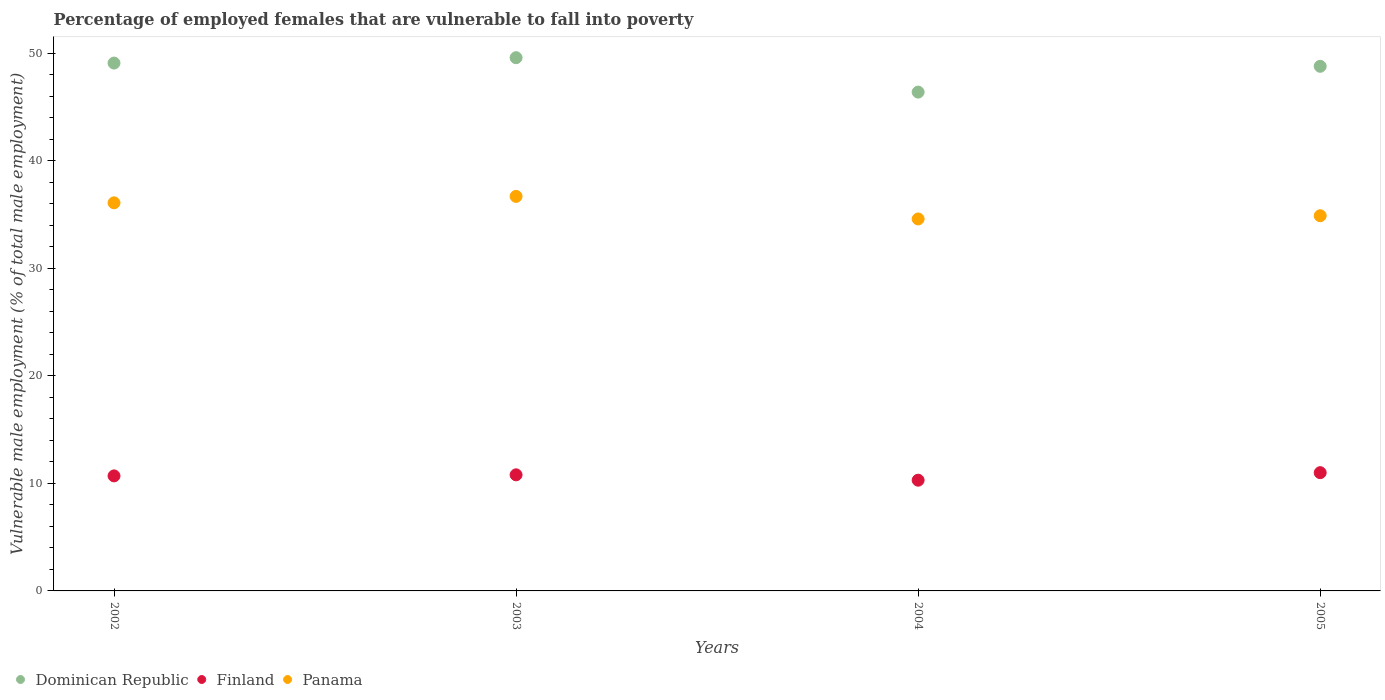Across all years, what is the maximum percentage of employed females who are vulnerable to fall into poverty in Dominican Republic?
Provide a short and direct response. 49.6. Across all years, what is the minimum percentage of employed females who are vulnerable to fall into poverty in Finland?
Provide a succinct answer. 10.3. In which year was the percentage of employed females who are vulnerable to fall into poverty in Dominican Republic maximum?
Provide a succinct answer. 2003. In which year was the percentage of employed females who are vulnerable to fall into poverty in Panama minimum?
Ensure brevity in your answer.  2004. What is the total percentage of employed females who are vulnerable to fall into poverty in Dominican Republic in the graph?
Your answer should be very brief. 193.9. What is the difference between the percentage of employed females who are vulnerable to fall into poverty in Finland in 2002 and that in 2003?
Provide a short and direct response. -0.1. What is the difference between the percentage of employed females who are vulnerable to fall into poverty in Dominican Republic in 2002 and the percentage of employed females who are vulnerable to fall into poverty in Panama in 2003?
Ensure brevity in your answer.  12.4. What is the average percentage of employed females who are vulnerable to fall into poverty in Finland per year?
Offer a very short reply. 10.7. In the year 2004, what is the difference between the percentage of employed females who are vulnerable to fall into poverty in Panama and percentage of employed females who are vulnerable to fall into poverty in Dominican Republic?
Your answer should be very brief. -11.8. What is the ratio of the percentage of employed females who are vulnerable to fall into poverty in Finland in 2002 to that in 2004?
Offer a terse response. 1.04. Is the difference between the percentage of employed females who are vulnerable to fall into poverty in Panama in 2003 and 2005 greater than the difference between the percentage of employed females who are vulnerable to fall into poverty in Dominican Republic in 2003 and 2005?
Provide a succinct answer. Yes. What is the difference between the highest and the second highest percentage of employed females who are vulnerable to fall into poverty in Finland?
Ensure brevity in your answer.  0.2. What is the difference between the highest and the lowest percentage of employed females who are vulnerable to fall into poverty in Dominican Republic?
Keep it short and to the point. 3.2. Is the sum of the percentage of employed females who are vulnerable to fall into poverty in Finland in 2003 and 2005 greater than the maximum percentage of employed females who are vulnerable to fall into poverty in Dominican Republic across all years?
Your response must be concise. No. Is it the case that in every year, the sum of the percentage of employed females who are vulnerable to fall into poverty in Panama and percentage of employed females who are vulnerable to fall into poverty in Finland  is greater than the percentage of employed females who are vulnerable to fall into poverty in Dominican Republic?
Provide a short and direct response. No. Does the percentage of employed females who are vulnerable to fall into poverty in Dominican Republic monotonically increase over the years?
Give a very brief answer. No. Is the percentage of employed females who are vulnerable to fall into poverty in Finland strictly greater than the percentage of employed females who are vulnerable to fall into poverty in Dominican Republic over the years?
Offer a very short reply. No. How many years are there in the graph?
Your answer should be very brief. 4. What is the difference between two consecutive major ticks on the Y-axis?
Keep it short and to the point. 10. Does the graph contain any zero values?
Ensure brevity in your answer.  No. Does the graph contain grids?
Your answer should be very brief. No. How many legend labels are there?
Your response must be concise. 3. How are the legend labels stacked?
Offer a terse response. Horizontal. What is the title of the graph?
Keep it short and to the point. Percentage of employed females that are vulnerable to fall into poverty. Does "Kiribati" appear as one of the legend labels in the graph?
Make the answer very short. No. What is the label or title of the Y-axis?
Make the answer very short. Vulnerable male employment (% of total male employment). What is the Vulnerable male employment (% of total male employment) in Dominican Republic in 2002?
Provide a short and direct response. 49.1. What is the Vulnerable male employment (% of total male employment) in Finland in 2002?
Offer a very short reply. 10.7. What is the Vulnerable male employment (% of total male employment) in Panama in 2002?
Make the answer very short. 36.1. What is the Vulnerable male employment (% of total male employment) of Dominican Republic in 2003?
Offer a terse response. 49.6. What is the Vulnerable male employment (% of total male employment) in Finland in 2003?
Make the answer very short. 10.8. What is the Vulnerable male employment (% of total male employment) of Panama in 2003?
Make the answer very short. 36.7. What is the Vulnerable male employment (% of total male employment) in Dominican Republic in 2004?
Keep it short and to the point. 46.4. What is the Vulnerable male employment (% of total male employment) in Finland in 2004?
Your response must be concise. 10.3. What is the Vulnerable male employment (% of total male employment) in Panama in 2004?
Offer a terse response. 34.6. What is the Vulnerable male employment (% of total male employment) of Dominican Republic in 2005?
Provide a short and direct response. 48.8. What is the Vulnerable male employment (% of total male employment) in Panama in 2005?
Your answer should be very brief. 34.9. Across all years, what is the maximum Vulnerable male employment (% of total male employment) in Dominican Republic?
Your answer should be very brief. 49.6. Across all years, what is the maximum Vulnerable male employment (% of total male employment) of Finland?
Provide a short and direct response. 11. Across all years, what is the maximum Vulnerable male employment (% of total male employment) of Panama?
Provide a short and direct response. 36.7. Across all years, what is the minimum Vulnerable male employment (% of total male employment) of Dominican Republic?
Keep it short and to the point. 46.4. Across all years, what is the minimum Vulnerable male employment (% of total male employment) of Finland?
Your response must be concise. 10.3. Across all years, what is the minimum Vulnerable male employment (% of total male employment) in Panama?
Your response must be concise. 34.6. What is the total Vulnerable male employment (% of total male employment) in Dominican Republic in the graph?
Your answer should be very brief. 193.9. What is the total Vulnerable male employment (% of total male employment) of Finland in the graph?
Your response must be concise. 42.8. What is the total Vulnerable male employment (% of total male employment) of Panama in the graph?
Provide a short and direct response. 142.3. What is the difference between the Vulnerable male employment (% of total male employment) of Dominican Republic in 2002 and that in 2003?
Offer a very short reply. -0.5. What is the difference between the Vulnerable male employment (% of total male employment) of Finland in 2002 and that in 2003?
Keep it short and to the point. -0.1. What is the difference between the Vulnerable male employment (% of total male employment) of Panama in 2002 and that in 2003?
Make the answer very short. -0.6. What is the difference between the Vulnerable male employment (% of total male employment) in Dominican Republic in 2002 and that in 2004?
Provide a succinct answer. 2.7. What is the difference between the Vulnerable male employment (% of total male employment) in Finland in 2002 and that in 2004?
Your answer should be very brief. 0.4. What is the difference between the Vulnerable male employment (% of total male employment) in Dominican Republic in 2002 and that in 2005?
Ensure brevity in your answer.  0.3. What is the difference between the Vulnerable male employment (% of total male employment) of Panama in 2002 and that in 2005?
Your answer should be compact. 1.2. What is the difference between the Vulnerable male employment (% of total male employment) of Panama in 2003 and that in 2004?
Offer a very short reply. 2.1. What is the difference between the Vulnerable male employment (% of total male employment) in Dominican Republic in 2004 and that in 2005?
Your answer should be very brief. -2.4. What is the difference between the Vulnerable male employment (% of total male employment) in Finland in 2004 and that in 2005?
Your answer should be compact. -0.7. What is the difference between the Vulnerable male employment (% of total male employment) in Dominican Republic in 2002 and the Vulnerable male employment (% of total male employment) in Finland in 2003?
Keep it short and to the point. 38.3. What is the difference between the Vulnerable male employment (% of total male employment) of Finland in 2002 and the Vulnerable male employment (% of total male employment) of Panama in 2003?
Make the answer very short. -26. What is the difference between the Vulnerable male employment (% of total male employment) in Dominican Republic in 2002 and the Vulnerable male employment (% of total male employment) in Finland in 2004?
Give a very brief answer. 38.8. What is the difference between the Vulnerable male employment (% of total male employment) in Dominican Republic in 2002 and the Vulnerable male employment (% of total male employment) in Panama in 2004?
Ensure brevity in your answer.  14.5. What is the difference between the Vulnerable male employment (% of total male employment) in Finland in 2002 and the Vulnerable male employment (% of total male employment) in Panama in 2004?
Ensure brevity in your answer.  -23.9. What is the difference between the Vulnerable male employment (% of total male employment) in Dominican Republic in 2002 and the Vulnerable male employment (% of total male employment) in Finland in 2005?
Offer a terse response. 38.1. What is the difference between the Vulnerable male employment (% of total male employment) in Finland in 2002 and the Vulnerable male employment (% of total male employment) in Panama in 2005?
Give a very brief answer. -24.2. What is the difference between the Vulnerable male employment (% of total male employment) in Dominican Republic in 2003 and the Vulnerable male employment (% of total male employment) in Finland in 2004?
Your answer should be compact. 39.3. What is the difference between the Vulnerable male employment (% of total male employment) of Dominican Republic in 2003 and the Vulnerable male employment (% of total male employment) of Panama in 2004?
Provide a succinct answer. 15. What is the difference between the Vulnerable male employment (% of total male employment) in Finland in 2003 and the Vulnerable male employment (% of total male employment) in Panama in 2004?
Your answer should be very brief. -23.8. What is the difference between the Vulnerable male employment (% of total male employment) in Dominican Republic in 2003 and the Vulnerable male employment (% of total male employment) in Finland in 2005?
Provide a short and direct response. 38.6. What is the difference between the Vulnerable male employment (% of total male employment) in Finland in 2003 and the Vulnerable male employment (% of total male employment) in Panama in 2005?
Offer a terse response. -24.1. What is the difference between the Vulnerable male employment (% of total male employment) of Dominican Republic in 2004 and the Vulnerable male employment (% of total male employment) of Finland in 2005?
Your answer should be compact. 35.4. What is the difference between the Vulnerable male employment (% of total male employment) in Finland in 2004 and the Vulnerable male employment (% of total male employment) in Panama in 2005?
Your answer should be compact. -24.6. What is the average Vulnerable male employment (% of total male employment) of Dominican Republic per year?
Your response must be concise. 48.48. What is the average Vulnerable male employment (% of total male employment) in Panama per year?
Ensure brevity in your answer.  35.58. In the year 2002, what is the difference between the Vulnerable male employment (% of total male employment) in Dominican Republic and Vulnerable male employment (% of total male employment) in Finland?
Offer a terse response. 38.4. In the year 2002, what is the difference between the Vulnerable male employment (% of total male employment) in Dominican Republic and Vulnerable male employment (% of total male employment) in Panama?
Make the answer very short. 13. In the year 2002, what is the difference between the Vulnerable male employment (% of total male employment) of Finland and Vulnerable male employment (% of total male employment) of Panama?
Provide a succinct answer. -25.4. In the year 2003, what is the difference between the Vulnerable male employment (% of total male employment) of Dominican Republic and Vulnerable male employment (% of total male employment) of Finland?
Ensure brevity in your answer.  38.8. In the year 2003, what is the difference between the Vulnerable male employment (% of total male employment) in Finland and Vulnerable male employment (% of total male employment) in Panama?
Keep it short and to the point. -25.9. In the year 2004, what is the difference between the Vulnerable male employment (% of total male employment) in Dominican Republic and Vulnerable male employment (% of total male employment) in Finland?
Make the answer very short. 36.1. In the year 2004, what is the difference between the Vulnerable male employment (% of total male employment) in Dominican Republic and Vulnerable male employment (% of total male employment) in Panama?
Ensure brevity in your answer.  11.8. In the year 2004, what is the difference between the Vulnerable male employment (% of total male employment) of Finland and Vulnerable male employment (% of total male employment) of Panama?
Make the answer very short. -24.3. In the year 2005, what is the difference between the Vulnerable male employment (% of total male employment) of Dominican Republic and Vulnerable male employment (% of total male employment) of Finland?
Offer a terse response. 37.8. In the year 2005, what is the difference between the Vulnerable male employment (% of total male employment) in Finland and Vulnerable male employment (% of total male employment) in Panama?
Your answer should be very brief. -23.9. What is the ratio of the Vulnerable male employment (% of total male employment) in Panama in 2002 to that in 2003?
Give a very brief answer. 0.98. What is the ratio of the Vulnerable male employment (% of total male employment) in Dominican Republic in 2002 to that in 2004?
Make the answer very short. 1.06. What is the ratio of the Vulnerable male employment (% of total male employment) of Finland in 2002 to that in 2004?
Keep it short and to the point. 1.04. What is the ratio of the Vulnerable male employment (% of total male employment) of Panama in 2002 to that in 2004?
Offer a terse response. 1.04. What is the ratio of the Vulnerable male employment (% of total male employment) in Dominican Republic in 2002 to that in 2005?
Provide a succinct answer. 1.01. What is the ratio of the Vulnerable male employment (% of total male employment) of Finland in 2002 to that in 2005?
Make the answer very short. 0.97. What is the ratio of the Vulnerable male employment (% of total male employment) in Panama in 2002 to that in 2005?
Keep it short and to the point. 1.03. What is the ratio of the Vulnerable male employment (% of total male employment) in Dominican Republic in 2003 to that in 2004?
Your response must be concise. 1.07. What is the ratio of the Vulnerable male employment (% of total male employment) in Finland in 2003 to that in 2004?
Keep it short and to the point. 1.05. What is the ratio of the Vulnerable male employment (% of total male employment) in Panama in 2003 to that in 2004?
Your answer should be very brief. 1.06. What is the ratio of the Vulnerable male employment (% of total male employment) in Dominican Republic in 2003 to that in 2005?
Your answer should be very brief. 1.02. What is the ratio of the Vulnerable male employment (% of total male employment) of Finland in 2003 to that in 2005?
Your answer should be very brief. 0.98. What is the ratio of the Vulnerable male employment (% of total male employment) in Panama in 2003 to that in 2005?
Your answer should be very brief. 1.05. What is the ratio of the Vulnerable male employment (% of total male employment) of Dominican Republic in 2004 to that in 2005?
Offer a very short reply. 0.95. What is the ratio of the Vulnerable male employment (% of total male employment) of Finland in 2004 to that in 2005?
Offer a terse response. 0.94. What is the difference between the highest and the second highest Vulnerable male employment (% of total male employment) in Finland?
Give a very brief answer. 0.2. What is the difference between the highest and the lowest Vulnerable male employment (% of total male employment) in Dominican Republic?
Your response must be concise. 3.2. 